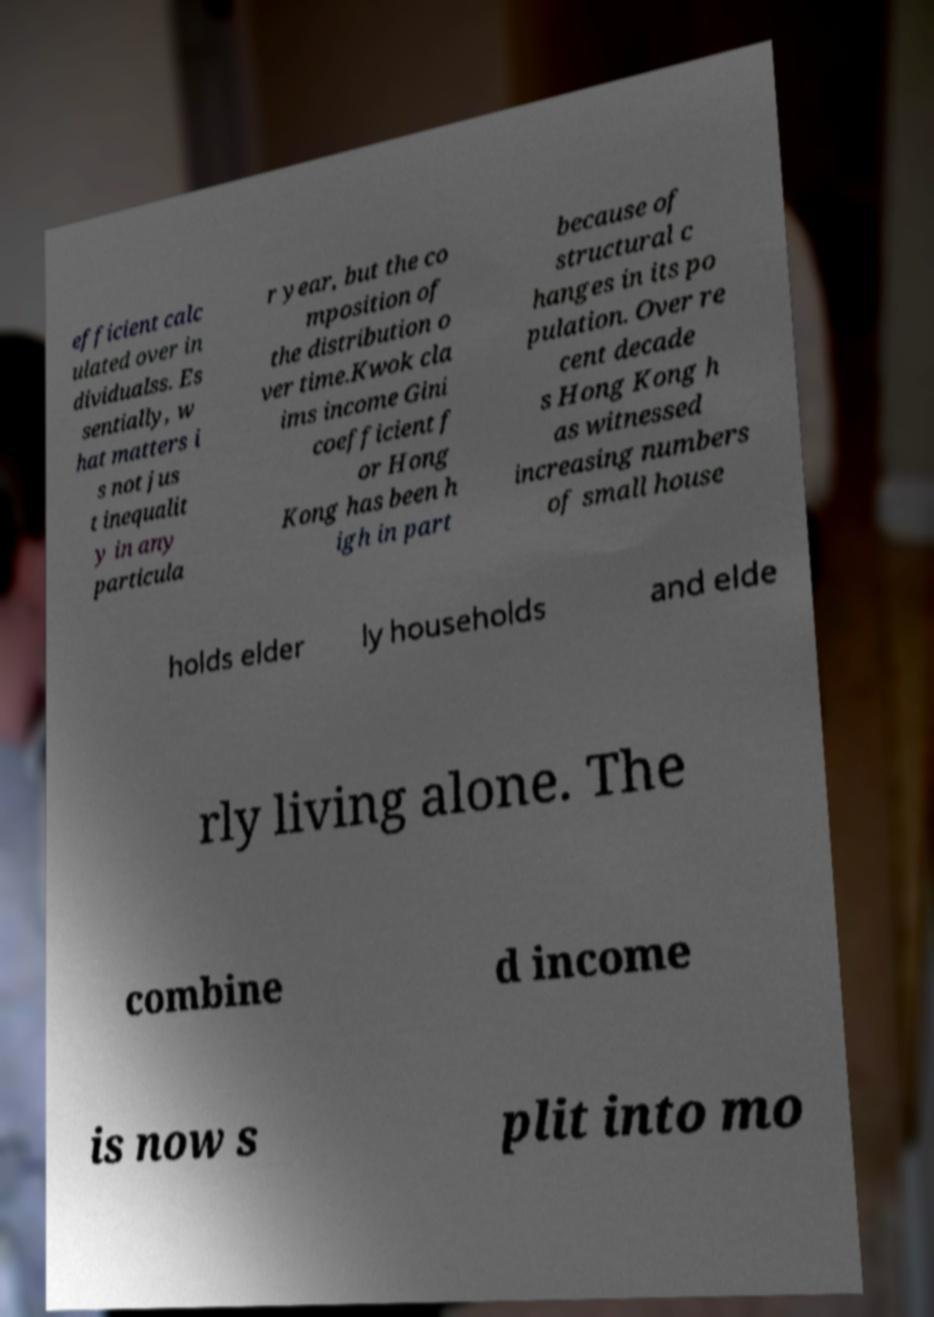Can you read and provide the text displayed in the image?This photo seems to have some interesting text. Can you extract and type it out for me? efficient calc ulated over in dividualss. Es sentially, w hat matters i s not jus t inequalit y in any particula r year, but the co mposition of the distribution o ver time.Kwok cla ims income Gini coefficient f or Hong Kong has been h igh in part because of structural c hanges in its po pulation. Over re cent decade s Hong Kong h as witnessed increasing numbers of small house holds elder ly households and elde rly living alone. The combine d income is now s plit into mo 